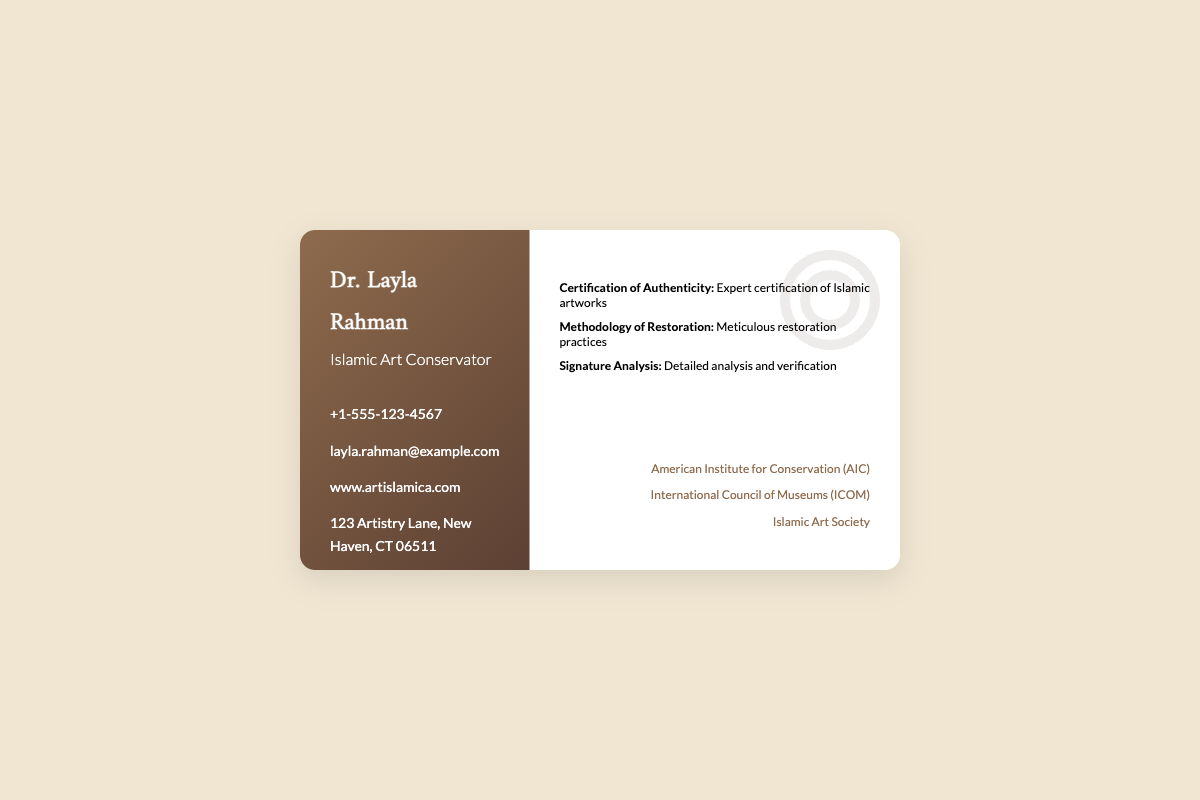what is the name on the business card? The name on the business card is prominently displayed at the top.
Answer: Dr. Layla Rahman what is Dr. Layla Rahman's profession? The profession is specified just below the name on the card.
Answer: Islamic Art Conservator what is the contact phone number? The contact phone number is listed in the contact information section.
Answer: +1-555-123-4567 which organization is Dr. Layla Rahman affiliated with? The affiliations are mentioned at the bottom right of the card, listing professional organizations.
Answer: American Institute for Conservation (AIC) what is one of the services provided? The services are outlined in the right side section of the business card.
Answer: Certification of Authenticity: Expert certification of Islamic artworks how many social media platforms are listed? The number of social media icons at the bottom left indicates the platforms.
Answer: Three what is the address listed on the business card? The address is provided in the contact information section of the business card.
Answer: 123 Artistry Lane, New Haven, CT 06511 what kind of analysis does Dr. Layla Rahman provide? The specific type of analysis is mentioned in the services section of the card.
Answer: Signature Analysis: Detailed analysis and verification what is the color scheme used in the business card? The background and text colors can be observed throughout the design of the card.
Answer: Brown and white 